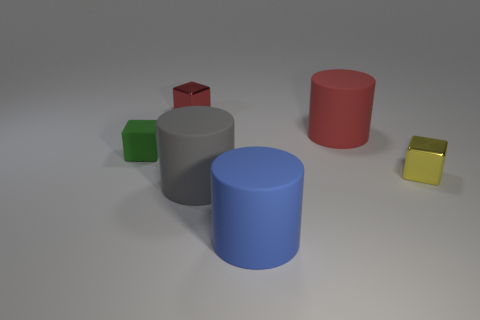Add 4 big red objects. How many objects exist? 10 Subtract 0 green cylinders. How many objects are left? 6 Subtract all tiny metal blocks. Subtract all big purple matte cylinders. How many objects are left? 4 Add 3 tiny green cubes. How many tiny green cubes are left? 4 Add 5 small red rubber cubes. How many small red rubber cubes exist? 5 